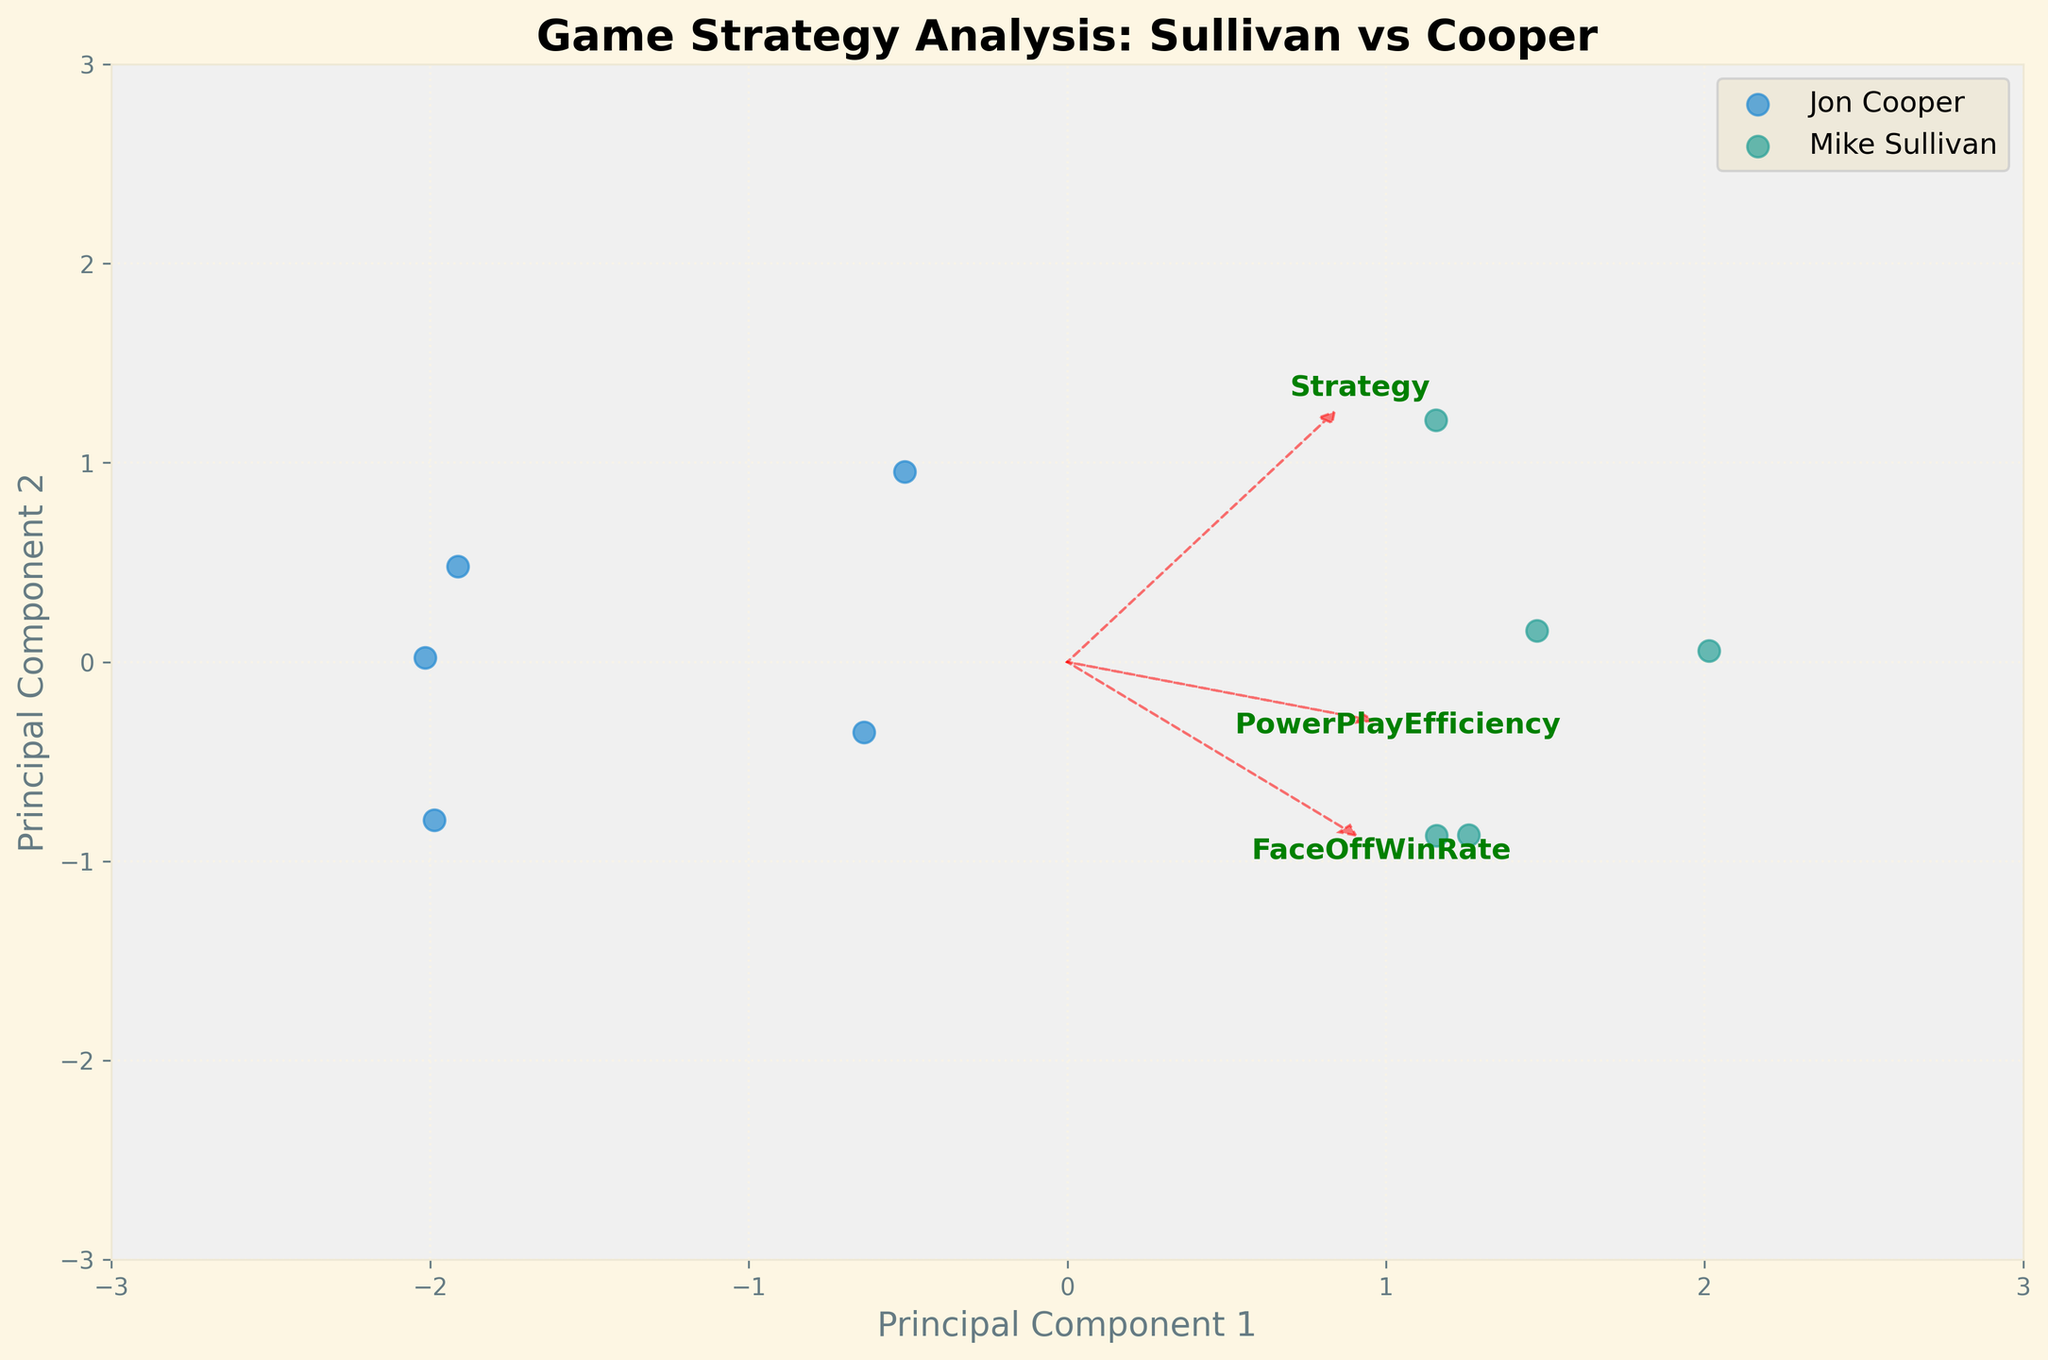What is the title of the plot? Look at the top of the plot. The title is usually displayed at the top in larger, bold font.
Answer: Game Strategy Analysis: Sullivan vs Cooper How many unique coaches are represented in the plot? Check the legend on the right side of the plot, which indicates the unique categories.
Answer: 2 Which principal component explains more variance, PC1 or PC2? The x-axis and y-axis represent PC1 and PC2 respectively. The length of the x-axis is typically longer, indicating it explains more variance.
Answer: PC1 Which coach has more data points on the left side of PC1? Identify both categories in the legend and count the points on the left side of the y-axis (PC1 < 0).
Answer: Jon Cooper Which game strategy has the highest power play efficiency? Locate the arrow corresponding to Power Play Efficiency; check the strategy farthest along this vector.
Answer: Aggressive Forecheck (Mike Sullivan) Which game strategy by Jon Cooper has the lowest face-off win rate? Inspect the strategies under Jon Cooper in the legend, then look along the arrow for Face-Off Win Rate, and find the one closest to the origin.
Answer: High Pressure What are the axes representing in the plot? The labels on the x-axis and y-axis mention 'Principal Component 1' and 'Principal Component 2'.
Answer: Principal Component 1 and Principal Component 2 Between Mike Sullivan and Jon Cooper, who has the strategy with the highest average Time On Ice Distribution? For each coach, calculate the average of their data points along the Time On Ice Distribution vector.
Answer: Mike Sullivan Which feature has the largest influence on PC1? Check the length and direction of arrows corresponding to each feature; the one with the longest arrow on PC1 (x-axis) has the largest influence.
Answer: Face-Off Win Rate Are strategies from the same coach clustered together or spread out in the plot? Observe the scatterplot and see if data points for each coach are grouped closely or dispersed.
Answer: Spread out 